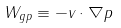<formula> <loc_0><loc_0><loc_500><loc_500>W _ { g p } \equiv - { v } \cdot \nabla p</formula> 